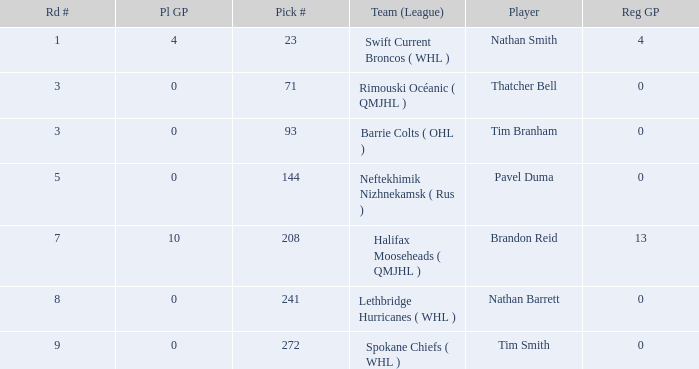How many reg GP for nathan barrett in a round less than 8? 0.0. 